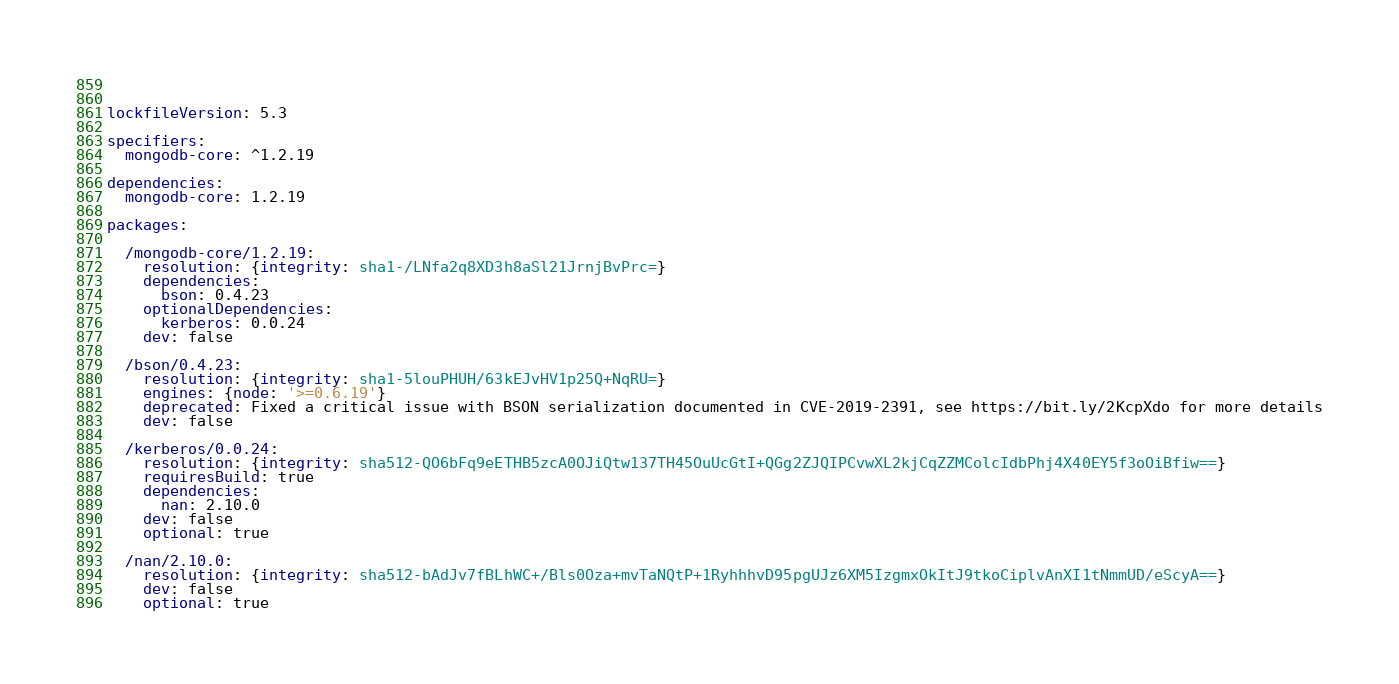Convert code to text. <code><loc_0><loc_0><loc_500><loc_500><_YAML_>  
  
lockfileVersion: 5.3

specifiers:
  mongodb-core: ^1.2.19

dependencies:
  mongodb-core: 1.2.19

packages:

  /mongodb-core/1.2.19:
    resolution: {integrity: sha1-/LNfa2q8XD3h8aSl21JrnjBvPrc=}
    dependencies:
      bson: 0.4.23
    optionalDependencies:
      kerberos: 0.0.24
    dev: false

  /bson/0.4.23:
    resolution: {integrity: sha1-5louPHUH/63kEJvHV1p25Q+NqRU=}
    engines: {node: '>=0.6.19'}
    deprecated: Fixed a critical issue with BSON serialization documented in CVE-2019-2391, see https://bit.ly/2KcpXdo for more details
    dev: false

  /kerberos/0.0.24:
    resolution: {integrity: sha512-QO6bFq9eETHB5zcA0OJiQtw137TH45OuUcGtI+QGg2ZJQIPCvwXL2kjCqZZMColcIdbPhj4X40EY5f3oOiBfiw==}
    requiresBuild: true
    dependencies:
      nan: 2.10.0
    dev: false
    optional: true

  /nan/2.10.0:
    resolution: {integrity: sha512-bAdJv7fBLhWC+/Bls0Oza+mvTaNQtP+1RyhhhvD95pgUJz6XM5IzgmxOkItJ9tkoCiplvAnXI1tNmmUD/eScyA==}
    dev: false
    optional: true</code> 